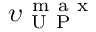Convert formula to latex. <formula><loc_0><loc_0><loc_500><loc_500>\upsilon _ { U P } ^ { m a x }</formula> 